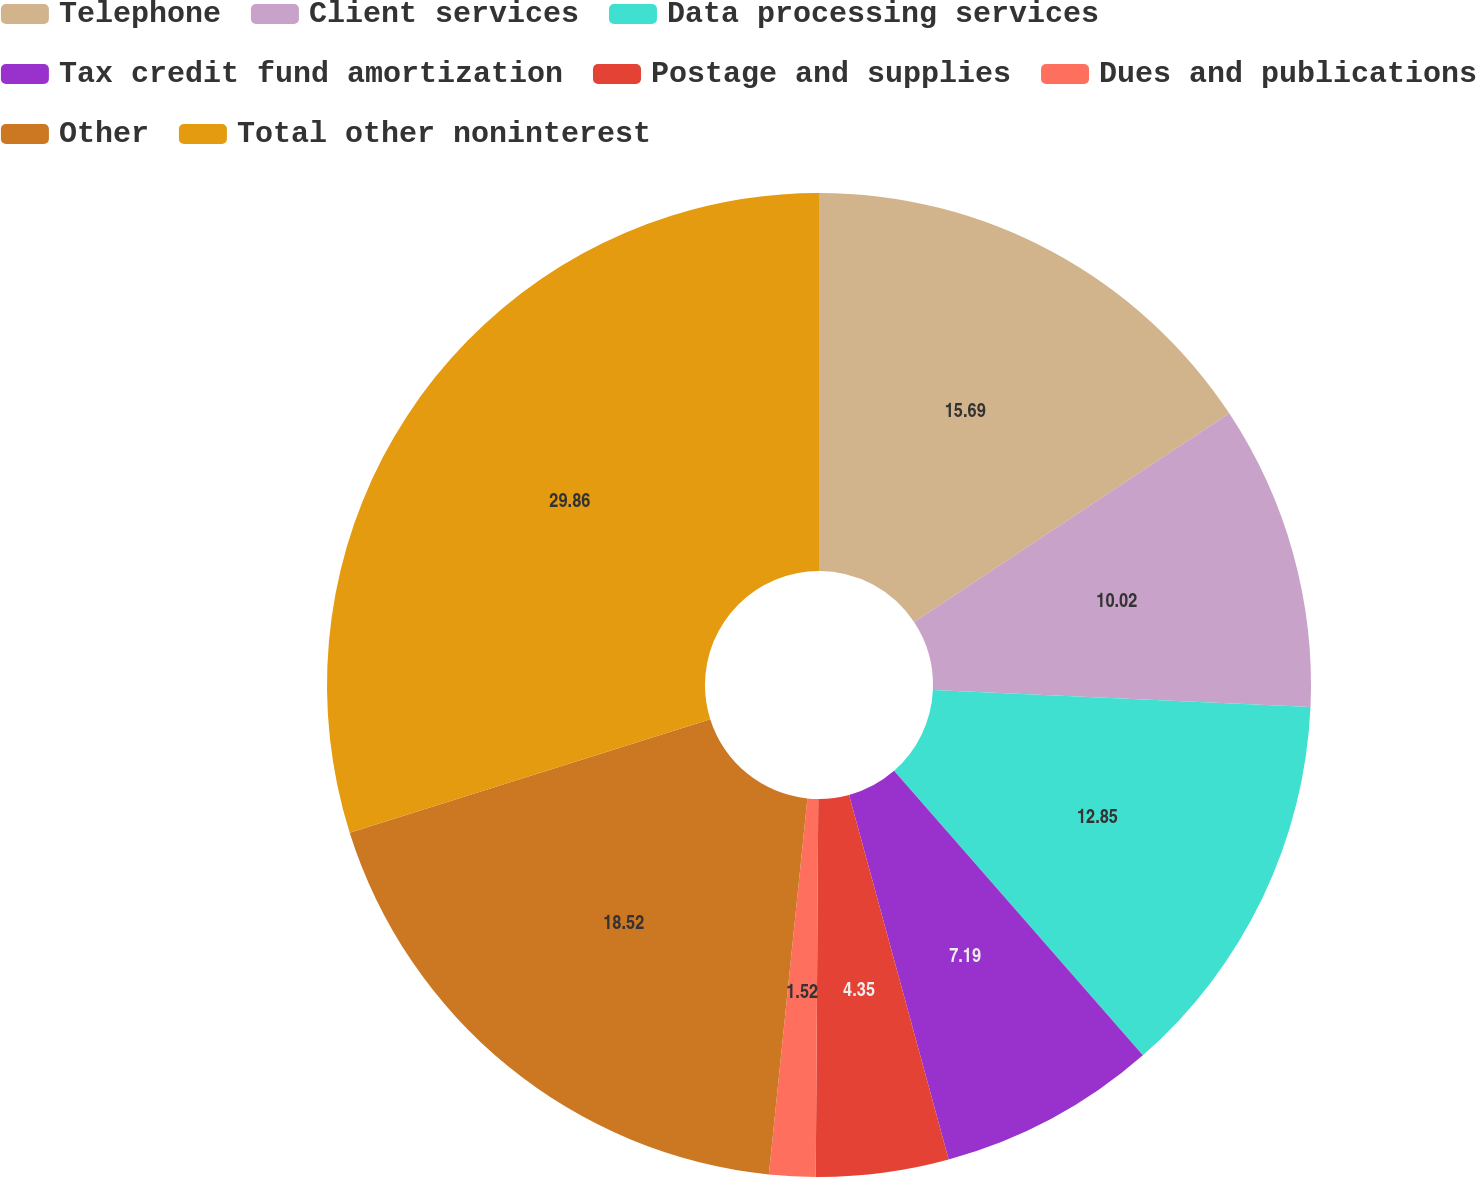Convert chart. <chart><loc_0><loc_0><loc_500><loc_500><pie_chart><fcel>Telephone<fcel>Client services<fcel>Data processing services<fcel>Tax credit fund amortization<fcel>Postage and supplies<fcel>Dues and publications<fcel>Other<fcel>Total other noninterest<nl><fcel>15.69%<fcel>10.02%<fcel>12.85%<fcel>7.19%<fcel>4.35%<fcel>1.52%<fcel>18.52%<fcel>29.85%<nl></chart> 